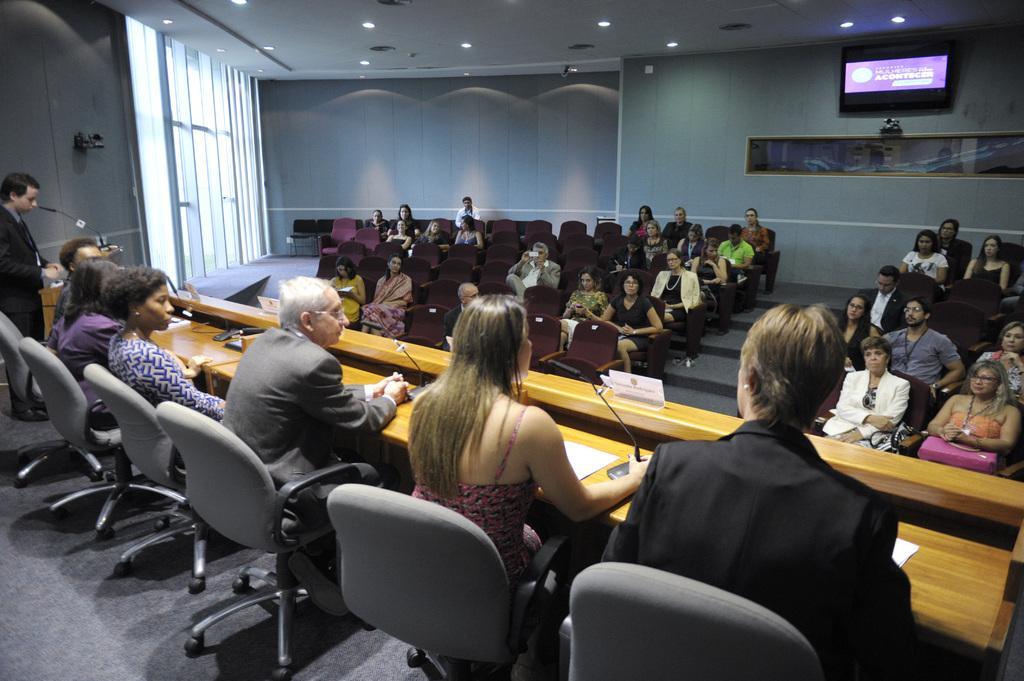How would you summarize this image in a sentence or two? It is a seminar hall, many people are sitting in the chairs, in front of them there are some other committee members sitting , one person is standing and speaking there is a table in front of them in the background there is a wall and windows and also a television. 